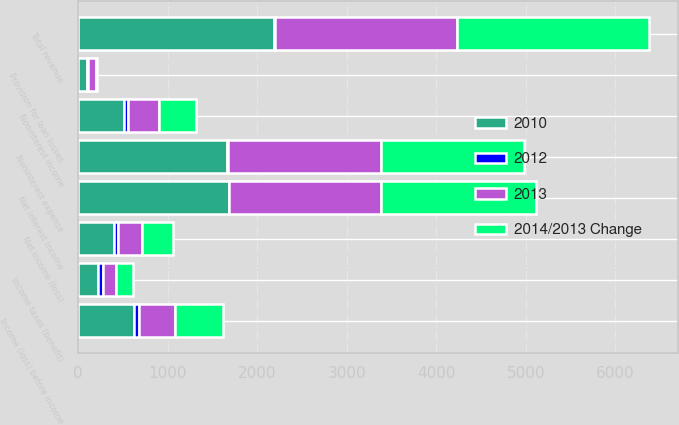Convert chart. <chart><loc_0><loc_0><loc_500><loc_500><stacked_bar_chart><ecel><fcel>Net interest income<fcel>Noninterest income<fcel>Total revenue<fcel>Provision for loan losses<fcel>Noninterest expense<fcel>Income (loss) before income<fcel>Income taxes (benefit)<fcel>Net income (loss)<nl><fcel>2012<fcel>1<fcel>51<fcel>8<fcel>13<fcel>3<fcel>53<fcel>56<fcel>51<nl><fcel>2010<fcel>1680<fcel>508.6<fcel>2188.6<fcel>98.1<fcel>1665.3<fcel>621.4<fcel>222.9<fcel>398.5<nl><fcel>2013<fcel>1696.3<fcel>337.4<fcel>2033.7<fcel>87.1<fcel>1714.4<fcel>406.4<fcel>142.9<fcel>263.5<nl><fcel>2014/2013 Change<fcel>1731.9<fcel>419.9<fcel>2151.8<fcel>14.2<fcel>1595<fcel>541.6<fcel>193.4<fcel>348.2<nl></chart> 